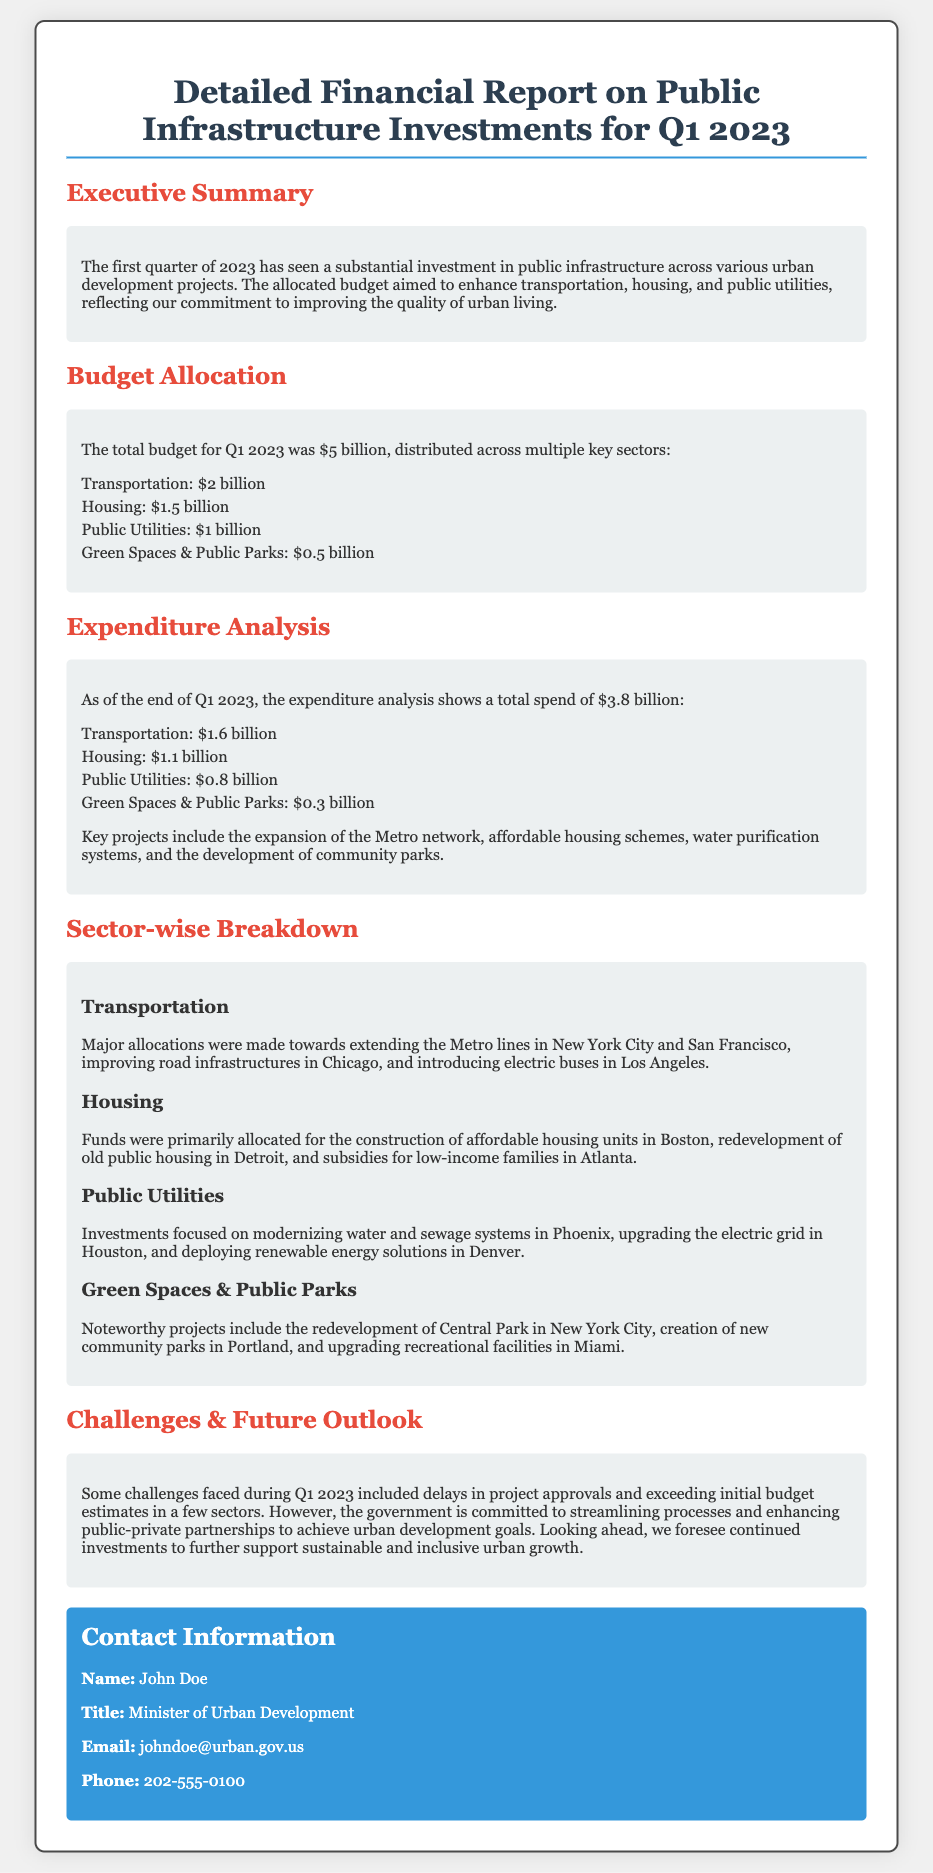What is the total budget for Q1 2023? The total budget for Q1 2023 is specified in the document as $5 billion.
Answer: $5 billion How much was allocated to Housing? The document outlines the budget allocation for Housing as $1.5 billion.
Answer: $1.5 billion What is the expenditure on Transportation? The total spend on Transportation is detailed as $1.6 billion in the expenditure analysis.
Answer: $1.6 billion What major project is mentioned under Green Spaces & Public Parks? The document highlights the redevelopment of Central Park in New York City as a noteworthy project.
Answer: Redevelopment of Central Park What challenges were faced during Q1 2023? The document states that delays in project approvals and exceeding initial budget estimates were challenges faced.
Answer: Delays in project approvals Who is the contact person for the report? The contact person mentioned in the report is John Doe.
Answer: John Doe What was the budget allocation for Public Utilities? The budget allocation for Public Utilities is listed as $1 billion.
Answer: $1 billion What city is mentioned for the expansion of Metro networks? The document mentions New York City for the expansion of Metro networks.
Answer: New York City 